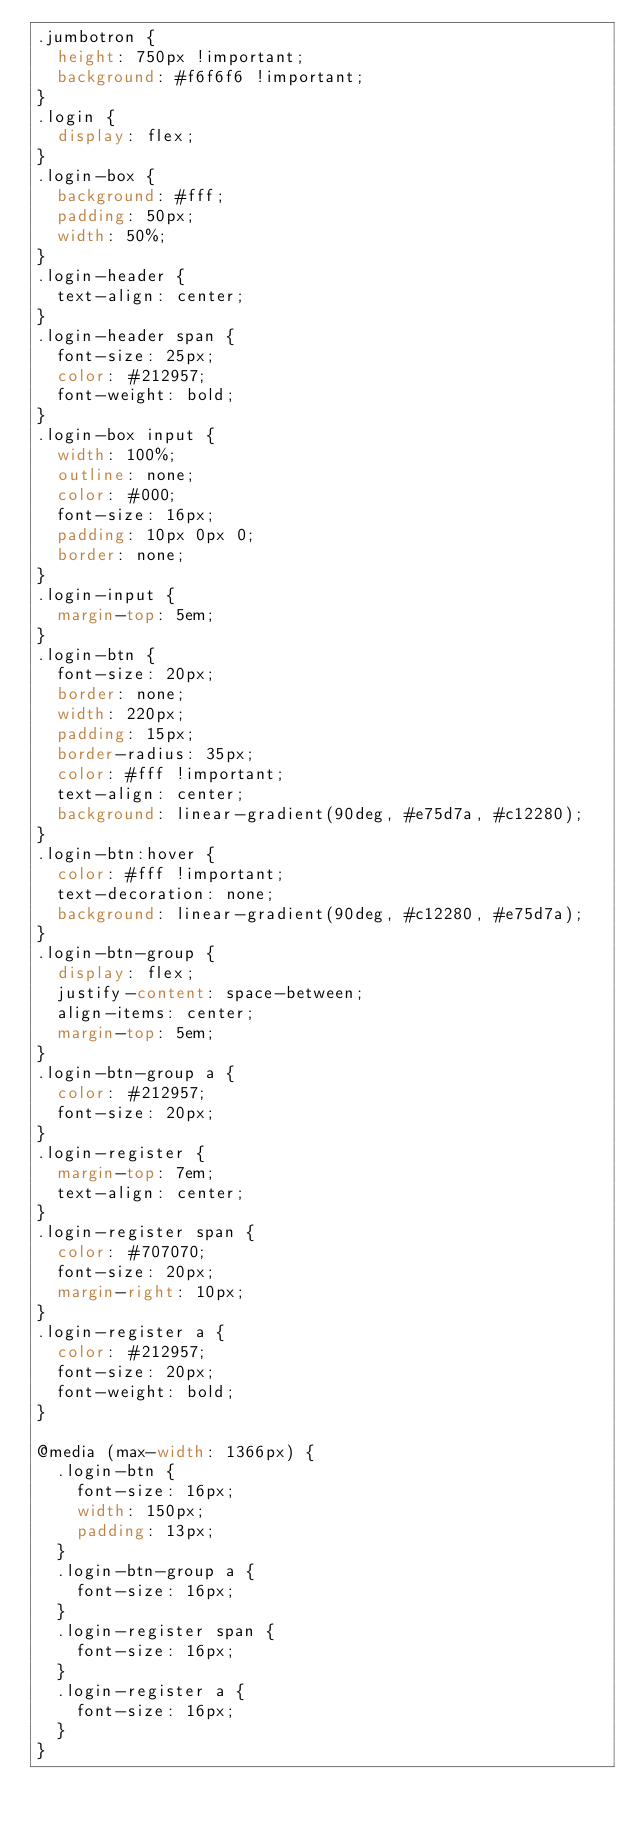Convert code to text. <code><loc_0><loc_0><loc_500><loc_500><_CSS_>.jumbotron {
  height: 750px !important;
  background: #f6f6f6 !important;
}
.login {
  display: flex;
}
.login-box {
  background: #fff;
  padding: 50px;
  width: 50%;
}
.login-header {
  text-align: center;
}
.login-header span {
  font-size: 25px;
  color: #212957;
  font-weight: bold;
}
.login-box input {
  width: 100%;
  outline: none;
  color: #000;
  font-size: 16px;
  padding: 10px 0px 0;
  border: none;
}
.login-input {
  margin-top: 5em;
}
.login-btn {
  font-size: 20px;
  border: none;
  width: 220px;
  padding: 15px;
  border-radius: 35px;
  color: #fff !important;
  text-align: center;
  background: linear-gradient(90deg, #e75d7a, #c12280);
}
.login-btn:hover {
  color: #fff !important;
  text-decoration: none;
  background: linear-gradient(90deg, #c12280, #e75d7a);
}
.login-btn-group {
  display: flex;
  justify-content: space-between;
  align-items: center;
  margin-top: 5em;
}
.login-btn-group a {
  color: #212957;
  font-size: 20px;
}
.login-register {
  margin-top: 7em;
  text-align: center;
}
.login-register span {
  color: #707070;
  font-size: 20px;
  margin-right: 10px;
}
.login-register a {
  color: #212957;
  font-size: 20px;
  font-weight: bold;
}

@media (max-width: 1366px) {
  .login-btn {
    font-size: 16px;
    width: 150px;
    padding: 13px;
  }
  .login-btn-group a {
    font-size: 16px;
  }
  .login-register span {
    font-size: 16px;
  }
  .login-register a {
    font-size: 16px;
  }
}
</code> 